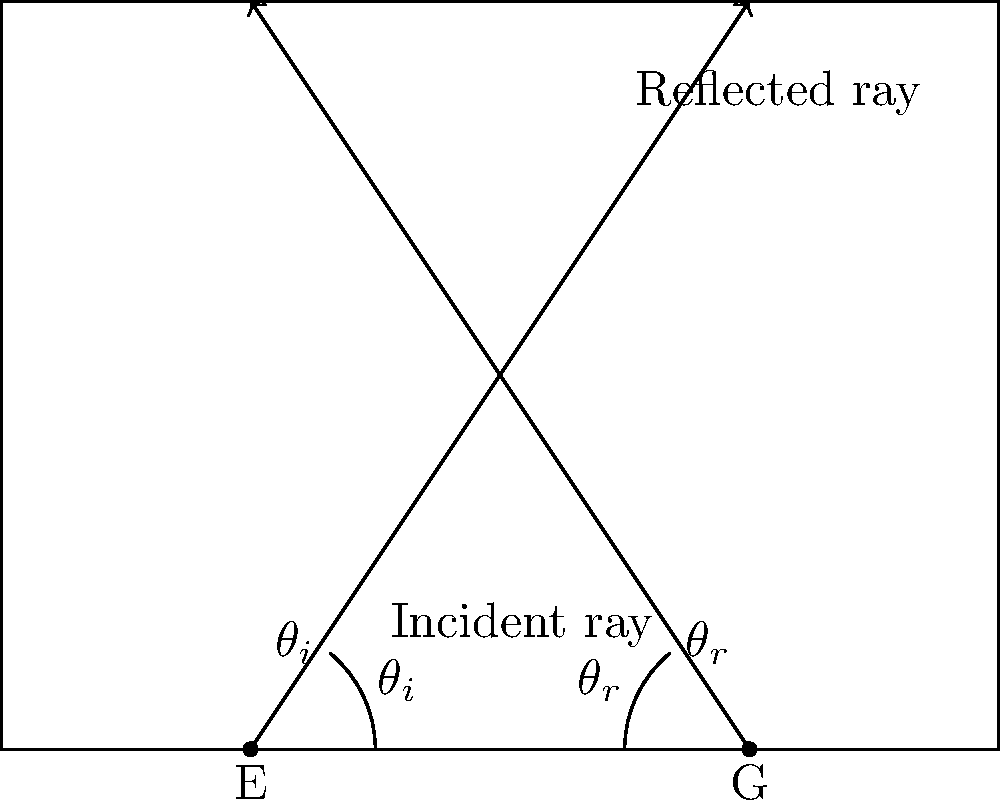In field hockey, when the ball bounces off the side boards, it follows a certain pattern. Look at the diagram showing a ball's path as it hits the side board. What's the relationship between the angle the ball comes in at (called the angle of incidence, $\theta_i$) and the angle it bounces off at (called the angle of reflection, $\theta_r$)? Let's break this down step-by-step:

1. In the diagram, we can see a ball's path as it hits the side board of a field hockey pitch.

2. The line coming towards the board is called the incident ray. It represents the ball's path before hitting the board.

3. The line going away from the board is called the reflected ray. It shows the ball's path after bouncing off the board.

4. The angle between the incident ray and the line perpendicular to the board (called the normal) is labeled $\theta_i$. This is known as the angle of incidence.

5. Similarly, the angle between the reflected ray and the normal is labeled $\theta_r$. This is called the angle of reflection.

6. In physics, there's a fundamental law called the Law of Reflection. This law states that for any reflecting surface (like our side board), the angle of incidence is always equal to the angle of reflection.

7. This means that $\theta_i = \theta_r$ for any bounce off the side board, regardless of how fast the ball is moving or where it hits the board.

8. This law is why players can predict where the ball will go after it hits the side board, which is crucial for strategy in field hockey.
Answer: $\theta_i = \theta_r$ 